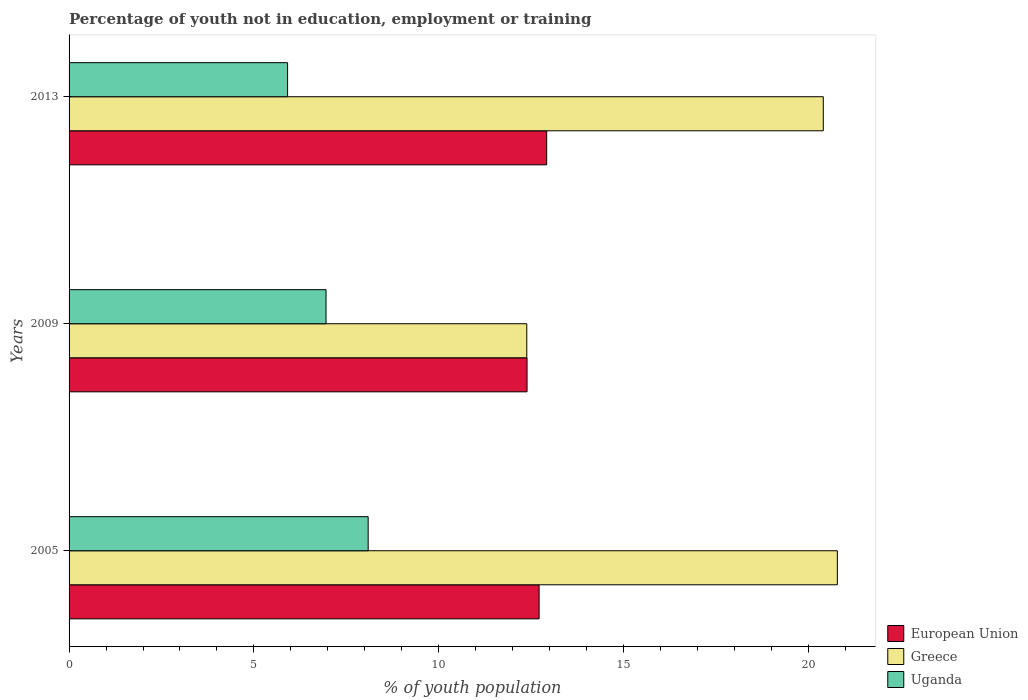How many groups of bars are there?
Keep it short and to the point. 3. Are the number of bars per tick equal to the number of legend labels?
Provide a short and direct response. Yes. Are the number of bars on each tick of the Y-axis equal?
Offer a very short reply. Yes. How many bars are there on the 1st tick from the bottom?
Your answer should be compact. 3. What is the percentage of unemployed youth population in in Uganda in 2009?
Give a very brief answer. 6.95. Across all years, what is the maximum percentage of unemployed youth population in in Greece?
Give a very brief answer. 20.78. Across all years, what is the minimum percentage of unemployed youth population in in Greece?
Your answer should be compact. 12.38. In which year was the percentage of unemployed youth population in in Greece maximum?
Keep it short and to the point. 2005. What is the total percentage of unemployed youth population in in Uganda in the graph?
Ensure brevity in your answer.  20.95. What is the difference between the percentage of unemployed youth population in in Uganda in 2005 and that in 2009?
Keep it short and to the point. 1.14. What is the difference between the percentage of unemployed youth population in in Greece in 2005 and the percentage of unemployed youth population in in European Union in 2013?
Your response must be concise. 7.86. What is the average percentage of unemployed youth population in in European Union per year?
Offer a very short reply. 12.67. In the year 2005, what is the difference between the percentage of unemployed youth population in in European Union and percentage of unemployed youth population in in Uganda?
Offer a very short reply. 4.62. What is the ratio of the percentage of unemployed youth population in in Uganda in 2009 to that in 2013?
Offer a very short reply. 1.18. Is the percentage of unemployed youth population in in Greece in 2005 less than that in 2009?
Provide a short and direct response. No. Is the difference between the percentage of unemployed youth population in in European Union in 2005 and 2009 greater than the difference between the percentage of unemployed youth population in in Uganda in 2005 and 2009?
Your answer should be very brief. No. What is the difference between the highest and the second highest percentage of unemployed youth population in in European Union?
Ensure brevity in your answer.  0.2. What is the difference between the highest and the lowest percentage of unemployed youth population in in Uganda?
Your answer should be very brief. 2.18. In how many years, is the percentage of unemployed youth population in in Greece greater than the average percentage of unemployed youth population in in Greece taken over all years?
Keep it short and to the point. 2. Is the sum of the percentage of unemployed youth population in in Uganda in 2009 and 2013 greater than the maximum percentage of unemployed youth population in in Greece across all years?
Give a very brief answer. No. What does the 3rd bar from the bottom in 2009 represents?
Your answer should be compact. Uganda. Is it the case that in every year, the sum of the percentage of unemployed youth population in in Greece and percentage of unemployed youth population in in Uganda is greater than the percentage of unemployed youth population in in European Union?
Offer a very short reply. Yes. Are all the bars in the graph horizontal?
Your response must be concise. Yes. How many years are there in the graph?
Offer a very short reply. 3. Are the values on the major ticks of X-axis written in scientific E-notation?
Keep it short and to the point. No. Does the graph contain any zero values?
Your answer should be compact. No. Does the graph contain grids?
Offer a very short reply. No. How are the legend labels stacked?
Make the answer very short. Vertical. What is the title of the graph?
Keep it short and to the point. Percentage of youth not in education, employment or training. What is the label or title of the X-axis?
Ensure brevity in your answer.  % of youth population. What is the % of youth population in European Union in 2005?
Offer a very short reply. 12.71. What is the % of youth population in Greece in 2005?
Your answer should be compact. 20.78. What is the % of youth population in Uganda in 2005?
Provide a short and direct response. 8.09. What is the % of youth population of European Union in 2009?
Provide a short and direct response. 12.39. What is the % of youth population of Greece in 2009?
Offer a very short reply. 12.38. What is the % of youth population of Uganda in 2009?
Offer a very short reply. 6.95. What is the % of youth population in European Union in 2013?
Make the answer very short. 12.92. What is the % of youth population of Greece in 2013?
Provide a short and direct response. 20.4. What is the % of youth population in Uganda in 2013?
Give a very brief answer. 5.91. Across all years, what is the maximum % of youth population in European Union?
Make the answer very short. 12.92. Across all years, what is the maximum % of youth population in Greece?
Provide a succinct answer. 20.78. Across all years, what is the maximum % of youth population in Uganda?
Provide a succinct answer. 8.09. Across all years, what is the minimum % of youth population in European Union?
Your answer should be compact. 12.39. Across all years, what is the minimum % of youth population of Greece?
Your answer should be compact. 12.38. Across all years, what is the minimum % of youth population of Uganda?
Give a very brief answer. 5.91. What is the total % of youth population in European Union in the graph?
Your response must be concise. 38.02. What is the total % of youth population in Greece in the graph?
Your answer should be very brief. 53.56. What is the total % of youth population in Uganda in the graph?
Your answer should be very brief. 20.95. What is the difference between the % of youth population of European Union in 2005 and that in 2009?
Ensure brevity in your answer.  0.33. What is the difference between the % of youth population of Greece in 2005 and that in 2009?
Your answer should be compact. 8.4. What is the difference between the % of youth population of Uganda in 2005 and that in 2009?
Provide a succinct answer. 1.14. What is the difference between the % of youth population of European Union in 2005 and that in 2013?
Keep it short and to the point. -0.2. What is the difference between the % of youth population of Greece in 2005 and that in 2013?
Offer a terse response. 0.38. What is the difference between the % of youth population in Uganda in 2005 and that in 2013?
Your answer should be compact. 2.18. What is the difference between the % of youth population in European Union in 2009 and that in 2013?
Offer a very short reply. -0.53. What is the difference between the % of youth population in Greece in 2009 and that in 2013?
Your answer should be compact. -8.02. What is the difference between the % of youth population of Uganda in 2009 and that in 2013?
Your answer should be very brief. 1.04. What is the difference between the % of youth population in European Union in 2005 and the % of youth population in Greece in 2009?
Give a very brief answer. 0.33. What is the difference between the % of youth population of European Union in 2005 and the % of youth population of Uganda in 2009?
Offer a very short reply. 5.76. What is the difference between the % of youth population of Greece in 2005 and the % of youth population of Uganda in 2009?
Your response must be concise. 13.83. What is the difference between the % of youth population in European Union in 2005 and the % of youth population in Greece in 2013?
Your answer should be compact. -7.69. What is the difference between the % of youth population of European Union in 2005 and the % of youth population of Uganda in 2013?
Keep it short and to the point. 6.8. What is the difference between the % of youth population in Greece in 2005 and the % of youth population in Uganda in 2013?
Your answer should be compact. 14.87. What is the difference between the % of youth population of European Union in 2009 and the % of youth population of Greece in 2013?
Your answer should be compact. -8.01. What is the difference between the % of youth population of European Union in 2009 and the % of youth population of Uganda in 2013?
Give a very brief answer. 6.48. What is the difference between the % of youth population in Greece in 2009 and the % of youth population in Uganda in 2013?
Ensure brevity in your answer.  6.47. What is the average % of youth population of European Union per year?
Give a very brief answer. 12.67. What is the average % of youth population of Greece per year?
Provide a short and direct response. 17.85. What is the average % of youth population of Uganda per year?
Offer a very short reply. 6.98. In the year 2005, what is the difference between the % of youth population in European Union and % of youth population in Greece?
Your response must be concise. -8.07. In the year 2005, what is the difference between the % of youth population in European Union and % of youth population in Uganda?
Offer a terse response. 4.62. In the year 2005, what is the difference between the % of youth population in Greece and % of youth population in Uganda?
Provide a short and direct response. 12.69. In the year 2009, what is the difference between the % of youth population in European Union and % of youth population in Greece?
Your response must be concise. 0.01. In the year 2009, what is the difference between the % of youth population of European Union and % of youth population of Uganda?
Your answer should be compact. 5.44. In the year 2009, what is the difference between the % of youth population of Greece and % of youth population of Uganda?
Ensure brevity in your answer.  5.43. In the year 2013, what is the difference between the % of youth population in European Union and % of youth population in Greece?
Your answer should be very brief. -7.48. In the year 2013, what is the difference between the % of youth population of European Union and % of youth population of Uganda?
Give a very brief answer. 7.01. In the year 2013, what is the difference between the % of youth population in Greece and % of youth population in Uganda?
Your answer should be very brief. 14.49. What is the ratio of the % of youth population in European Union in 2005 to that in 2009?
Provide a short and direct response. 1.03. What is the ratio of the % of youth population in Greece in 2005 to that in 2009?
Make the answer very short. 1.68. What is the ratio of the % of youth population of Uganda in 2005 to that in 2009?
Give a very brief answer. 1.16. What is the ratio of the % of youth population in European Union in 2005 to that in 2013?
Provide a succinct answer. 0.98. What is the ratio of the % of youth population in Greece in 2005 to that in 2013?
Keep it short and to the point. 1.02. What is the ratio of the % of youth population in Uganda in 2005 to that in 2013?
Provide a short and direct response. 1.37. What is the ratio of the % of youth population in European Union in 2009 to that in 2013?
Give a very brief answer. 0.96. What is the ratio of the % of youth population of Greece in 2009 to that in 2013?
Your answer should be very brief. 0.61. What is the ratio of the % of youth population in Uganda in 2009 to that in 2013?
Provide a succinct answer. 1.18. What is the difference between the highest and the second highest % of youth population in European Union?
Your answer should be very brief. 0.2. What is the difference between the highest and the second highest % of youth population in Greece?
Offer a terse response. 0.38. What is the difference between the highest and the second highest % of youth population of Uganda?
Provide a succinct answer. 1.14. What is the difference between the highest and the lowest % of youth population of European Union?
Offer a very short reply. 0.53. What is the difference between the highest and the lowest % of youth population in Uganda?
Your response must be concise. 2.18. 